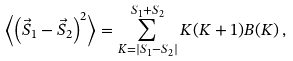<formula> <loc_0><loc_0><loc_500><loc_500>\left \langle \left ( \vec { S } _ { 1 } - \vec { S } _ { 2 } \right ) ^ { 2 } \right \rangle = \sum _ { K = | S _ { 1 } - S _ { 2 } | } ^ { S _ { 1 } + S _ { 2 } } K ( K + 1 ) B ( K ) \, ,</formula> 